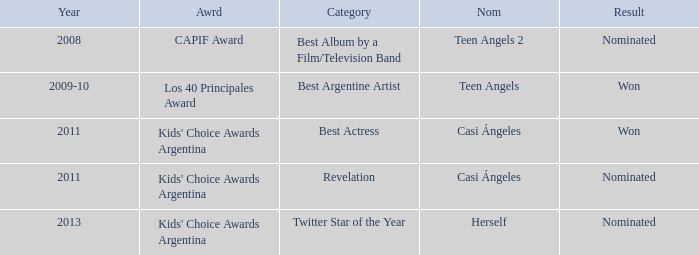What year was Teen Angels 2 nominated? 2008.0. 